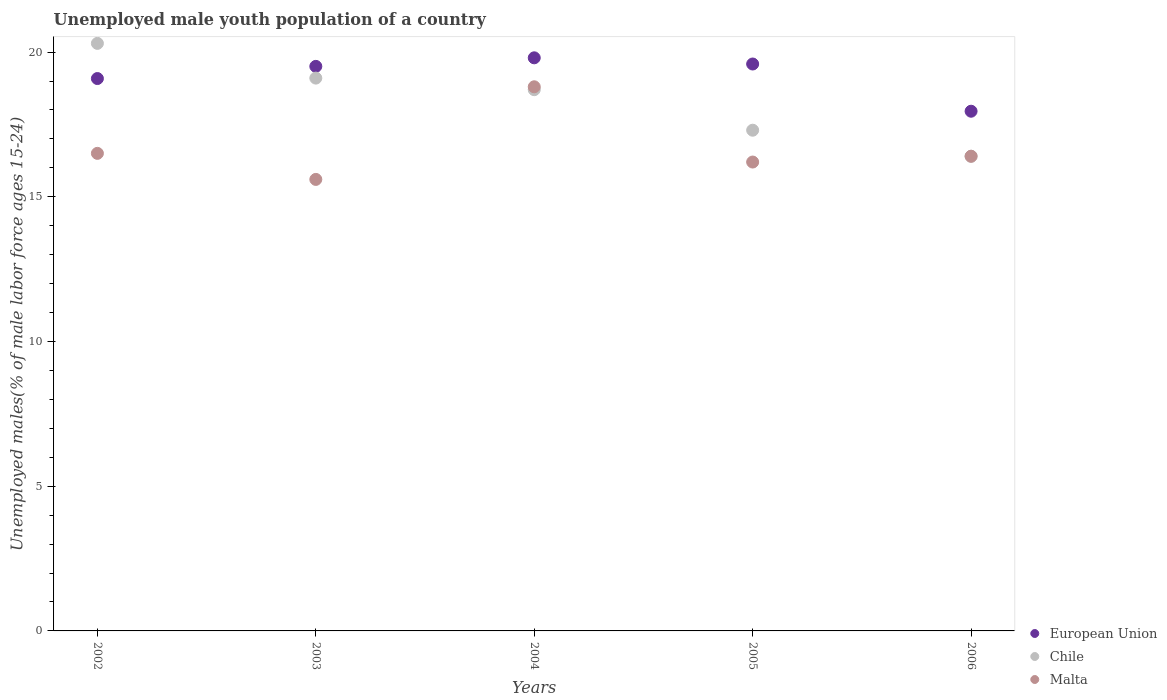Is the number of dotlines equal to the number of legend labels?
Provide a short and direct response. Yes. What is the percentage of unemployed male youth population in European Union in 2003?
Ensure brevity in your answer.  19.51. Across all years, what is the maximum percentage of unemployed male youth population in European Union?
Offer a very short reply. 19.8. Across all years, what is the minimum percentage of unemployed male youth population in Chile?
Make the answer very short. 16.4. In which year was the percentage of unemployed male youth population in Malta maximum?
Provide a succinct answer. 2004. What is the total percentage of unemployed male youth population in Malta in the graph?
Ensure brevity in your answer.  83.5. What is the difference between the percentage of unemployed male youth population in European Union in 2003 and that in 2006?
Ensure brevity in your answer.  1.55. What is the average percentage of unemployed male youth population in Chile per year?
Provide a succinct answer. 18.36. In the year 2003, what is the difference between the percentage of unemployed male youth population in European Union and percentage of unemployed male youth population in Malta?
Your response must be concise. 3.91. What is the ratio of the percentage of unemployed male youth population in European Union in 2002 to that in 2005?
Ensure brevity in your answer.  0.97. Is the percentage of unemployed male youth population in European Union in 2002 less than that in 2006?
Your answer should be compact. No. What is the difference between the highest and the second highest percentage of unemployed male youth population in European Union?
Provide a short and direct response. 0.21. What is the difference between the highest and the lowest percentage of unemployed male youth population in Malta?
Provide a short and direct response. 3.2. In how many years, is the percentage of unemployed male youth population in European Union greater than the average percentage of unemployed male youth population in European Union taken over all years?
Provide a succinct answer. 3. Is the percentage of unemployed male youth population in Chile strictly less than the percentage of unemployed male youth population in Malta over the years?
Offer a terse response. No. How many years are there in the graph?
Give a very brief answer. 5. What is the difference between two consecutive major ticks on the Y-axis?
Give a very brief answer. 5. Are the values on the major ticks of Y-axis written in scientific E-notation?
Your answer should be compact. No. How many legend labels are there?
Your response must be concise. 3. How are the legend labels stacked?
Keep it short and to the point. Vertical. What is the title of the graph?
Your answer should be very brief. Unemployed male youth population of a country. Does "High income: OECD" appear as one of the legend labels in the graph?
Keep it short and to the point. No. What is the label or title of the Y-axis?
Your answer should be compact. Unemployed males(% of male labor force ages 15-24). What is the Unemployed males(% of male labor force ages 15-24) in European Union in 2002?
Give a very brief answer. 19.08. What is the Unemployed males(% of male labor force ages 15-24) in Chile in 2002?
Your response must be concise. 20.3. What is the Unemployed males(% of male labor force ages 15-24) of Malta in 2002?
Offer a terse response. 16.5. What is the Unemployed males(% of male labor force ages 15-24) in European Union in 2003?
Offer a terse response. 19.51. What is the Unemployed males(% of male labor force ages 15-24) of Chile in 2003?
Provide a short and direct response. 19.1. What is the Unemployed males(% of male labor force ages 15-24) in Malta in 2003?
Offer a very short reply. 15.6. What is the Unemployed males(% of male labor force ages 15-24) of European Union in 2004?
Make the answer very short. 19.8. What is the Unemployed males(% of male labor force ages 15-24) in Chile in 2004?
Make the answer very short. 18.7. What is the Unemployed males(% of male labor force ages 15-24) in Malta in 2004?
Provide a succinct answer. 18.8. What is the Unemployed males(% of male labor force ages 15-24) of European Union in 2005?
Offer a terse response. 19.59. What is the Unemployed males(% of male labor force ages 15-24) in Chile in 2005?
Ensure brevity in your answer.  17.3. What is the Unemployed males(% of male labor force ages 15-24) of Malta in 2005?
Your response must be concise. 16.2. What is the Unemployed males(% of male labor force ages 15-24) of European Union in 2006?
Provide a short and direct response. 17.96. What is the Unemployed males(% of male labor force ages 15-24) in Chile in 2006?
Offer a very short reply. 16.4. What is the Unemployed males(% of male labor force ages 15-24) of Malta in 2006?
Give a very brief answer. 16.4. Across all years, what is the maximum Unemployed males(% of male labor force ages 15-24) in European Union?
Offer a terse response. 19.8. Across all years, what is the maximum Unemployed males(% of male labor force ages 15-24) in Chile?
Provide a short and direct response. 20.3. Across all years, what is the maximum Unemployed males(% of male labor force ages 15-24) in Malta?
Give a very brief answer. 18.8. Across all years, what is the minimum Unemployed males(% of male labor force ages 15-24) of European Union?
Your answer should be very brief. 17.96. Across all years, what is the minimum Unemployed males(% of male labor force ages 15-24) in Chile?
Keep it short and to the point. 16.4. Across all years, what is the minimum Unemployed males(% of male labor force ages 15-24) in Malta?
Make the answer very short. 15.6. What is the total Unemployed males(% of male labor force ages 15-24) of European Union in the graph?
Provide a succinct answer. 95.93. What is the total Unemployed males(% of male labor force ages 15-24) in Chile in the graph?
Your answer should be compact. 91.8. What is the total Unemployed males(% of male labor force ages 15-24) of Malta in the graph?
Your answer should be compact. 83.5. What is the difference between the Unemployed males(% of male labor force ages 15-24) in European Union in 2002 and that in 2003?
Offer a terse response. -0.42. What is the difference between the Unemployed males(% of male labor force ages 15-24) in European Union in 2002 and that in 2004?
Your response must be concise. -0.72. What is the difference between the Unemployed males(% of male labor force ages 15-24) in Chile in 2002 and that in 2004?
Keep it short and to the point. 1.6. What is the difference between the Unemployed males(% of male labor force ages 15-24) in Malta in 2002 and that in 2004?
Provide a short and direct response. -2.3. What is the difference between the Unemployed males(% of male labor force ages 15-24) in European Union in 2002 and that in 2005?
Provide a succinct answer. -0.5. What is the difference between the Unemployed males(% of male labor force ages 15-24) in European Union in 2002 and that in 2006?
Your answer should be compact. 1.13. What is the difference between the Unemployed males(% of male labor force ages 15-24) in European Union in 2003 and that in 2004?
Keep it short and to the point. -0.3. What is the difference between the Unemployed males(% of male labor force ages 15-24) of Malta in 2003 and that in 2004?
Make the answer very short. -3.2. What is the difference between the Unemployed males(% of male labor force ages 15-24) of European Union in 2003 and that in 2005?
Your answer should be compact. -0.08. What is the difference between the Unemployed males(% of male labor force ages 15-24) of Chile in 2003 and that in 2005?
Your answer should be very brief. 1.8. What is the difference between the Unemployed males(% of male labor force ages 15-24) of Malta in 2003 and that in 2005?
Your answer should be compact. -0.6. What is the difference between the Unemployed males(% of male labor force ages 15-24) of European Union in 2003 and that in 2006?
Ensure brevity in your answer.  1.55. What is the difference between the Unemployed males(% of male labor force ages 15-24) of Chile in 2003 and that in 2006?
Make the answer very short. 2.7. What is the difference between the Unemployed males(% of male labor force ages 15-24) of European Union in 2004 and that in 2005?
Give a very brief answer. 0.21. What is the difference between the Unemployed males(% of male labor force ages 15-24) in Malta in 2004 and that in 2005?
Give a very brief answer. 2.6. What is the difference between the Unemployed males(% of male labor force ages 15-24) of European Union in 2004 and that in 2006?
Ensure brevity in your answer.  1.85. What is the difference between the Unemployed males(% of male labor force ages 15-24) in European Union in 2005 and that in 2006?
Provide a succinct answer. 1.63. What is the difference between the Unemployed males(% of male labor force ages 15-24) in Malta in 2005 and that in 2006?
Keep it short and to the point. -0.2. What is the difference between the Unemployed males(% of male labor force ages 15-24) in European Union in 2002 and the Unemployed males(% of male labor force ages 15-24) in Chile in 2003?
Offer a terse response. -0.02. What is the difference between the Unemployed males(% of male labor force ages 15-24) in European Union in 2002 and the Unemployed males(% of male labor force ages 15-24) in Malta in 2003?
Keep it short and to the point. 3.48. What is the difference between the Unemployed males(% of male labor force ages 15-24) of Chile in 2002 and the Unemployed males(% of male labor force ages 15-24) of Malta in 2003?
Offer a very short reply. 4.7. What is the difference between the Unemployed males(% of male labor force ages 15-24) in European Union in 2002 and the Unemployed males(% of male labor force ages 15-24) in Chile in 2004?
Provide a short and direct response. 0.38. What is the difference between the Unemployed males(% of male labor force ages 15-24) of European Union in 2002 and the Unemployed males(% of male labor force ages 15-24) of Malta in 2004?
Provide a short and direct response. 0.28. What is the difference between the Unemployed males(% of male labor force ages 15-24) in European Union in 2002 and the Unemployed males(% of male labor force ages 15-24) in Chile in 2005?
Your answer should be compact. 1.78. What is the difference between the Unemployed males(% of male labor force ages 15-24) in European Union in 2002 and the Unemployed males(% of male labor force ages 15-24) in Malta in 2005?
Your response must be concise. 2.88. What is the difference between the Unemployed males(% of male labor force ages 15-24) in Chile in 2002 and the Unemployed males(% of male labor force ages 15-24) in Malta in 2005?
Your answer should be very brief. 4.1. What is the difference between the Unemployed males(% of male labor force ages 15-24) of European Union in 2002 and the Unemployed males(% of male labor force ages 15-24) of Chile in 2006?
Provide a succinct answer. 2.68. What is the difference between the Unemployed males(% of male labor force ages 15-24) in European Union in 2002 and the Unemployed males(% of male labor force ages 15-24) in Malta in 2006?
Your response must be concise. 2.68. What is the difference between the Unemployed males(% of male labor force ages 15-24) in European Union in 2003 and the Unemployed males(% of male labor force ages 15-24) in Chile in 2004?
Provide a succinct answer. 0.81. What is the difference between the Unemployed males(% of male labor force ages 15-24) of European Union in 2003 and the Unemployed males(% of male labor force ages 15-24) of Malta in 2004?
Give a very brief answer. 0.71. What is the difference between the Unemployed males(% of male labor force ages 15-24) in European Union in 2003 and the Unemployed males(% of male labor force ages 15-24) in Chile in 2005?
Offer a terse response. 2.21. What is the difference between the Unemployed males(% of male labor force ages 15-24) in European Union in 2003 and the Unemployed males(% of male labor force ages 15-24) in Malta in 2005?
Provide a succinct answer. 3.31. What is the difference between the Unemployed males(% of male labor force ages 15-24) in Chile in 2003 and the Unemployed males(% of male labor force ages 15-24) in Malta in 2005?
Your response must be concise. 2.9. What is the difference between the Unemployed males(% of male labor force ages 15-24) of European Union in 2003 and the Unemployed males(% of male labor force ages 15-24) of Chile in 2006?
Offer a very short reply. 3.11. What is the difference between the Unemployed males(% of male labor force ages 15-24) of European Union in 2003 and the Unemployed males(% of male labor force ages 15-24) of Malta in 2006?
Keep it short and to the point. 3.11. What is the difference between the Unemployed males(% of male labor force ages 15-24) of European Union in 2004 and the Unemployed males(% of male labor force ages 15-24) of Chile in 2005?
Provide a succinct answer. 2.5. What is the difference between the Unemployed males(% of male labor force ages 15-24) of European Union in 2004 and the Unemployed males(% of male labor force ages 15-24) of Malta in 2005?
Your response must be concise. 3.6. What is the difference between the Unemployed males(% of male labor force ages 15-24) in European Union in 2004 and the Unemployed males(% of male labor force ages 15-24) in Chile in 2006?
Keep it short and to the point. 3.4. What is the difference between the Unemployed males(% of male labor force ages 15-24) of European Union in 2004 and the Unemployed males(% of male labor force ages 15-24) of Malta in 2006?
Offer a very short reply. 3.4. What is the difference between the Unemployed males(% of male labor force ages 15-24) in Chile in 2004 and the Unemployed males(% of male labor force ages 15-24) in Malta in 2006?
Offer a terse response. 2.3. What is the difference between the Unemployed males(% of male labor force ages 15-24) in European Union in 2005 and the Unemployed males(% of male labor force ages 15-24) in Chile in 2006?
Provide a short and direct response. 3.19. What is the difference between the Unemployed males(% of male labor force ages 15-24) in European Union in 2005 and the Unemployed males(% of male labor force ages 15-24) in Malta in 2006?
Offer a terse response. 3.19. What is the difference between the Unemployed males(% of male labor force ages 15-24) in Chile in 2005 and the Unemployed males(% of male labor force ages 15-24) in Malta in 2006?
Your answer should be compact. 0.9. What is the average Unemployed males(% of male labor force ages 15-24) in European Union per year?
Your answer should be very brief. 19.19. What is the average Unemployed males(% of male labor force ages 15-24) of Chile per year?
Offer a very short reply. 18.36. What is the average Unemployed males(% of male labor force ages 15-24) in Malta per year?
Offer a very short reply. 16.7. In the year 2002, what is the difference between the Unemployed males(% of male labor force ages 15-24) in European Union and Unemployed males(% of male labor force ages 15-24) in Chile?
Keep it short and to the point. -1.22. In the year 2002, what is the difference between the Unemployed males(% of male labor force ages 15-24) in European Union and Unemployed males(% of male labor force ages 15-24) in Malta?
Ensure brevity in your answer.  2.58. In the year 2003, what is the difference between the Unemployed males(% of male labor force ages 15-24) of European Union and Unemployed males(% of male labor force ages 15-24) of Chile?
Your answer should be compact. 0.41. In the year 2003, what is the difference between the Unemployed males(% of male labor force ages 15-24) of European Union and Unemployed males(% of male labor force ages 15-24) of Malta?
Your response must be concise. 3.91. In the year 2004, what is the difference between the Unemployed males(% of male labor force ages 15-24) of European Union and Unemployed males(% of male labor force ages 15-24) of Chile?
Your answer should be compact. 1.1. In the year 2004, what is the difference between the Unemployed males(% of male labor force ages 15-24) of European Union and Unemployed males(% of male labor force ages 15-24) of Malta?
Make the answer very short. 1. In the year 2005, what is the difference between the Unemployed males(% of male labor force ages 15-24) of European Union and Unemployed males(% of male labor force ages 15-24) of Chile?
Your response must be concise. 2.29. In the year 2005, what is the difference between the Unemployed males(% of male labor force ages 15-24) in European Union and Unemployed males(% of male labor force ages 15-24) in Malta?
Your answer should be compact. 3.39. In the year 2005, what is the difference between the Unemployed males(% of male labor force ages 15-24) of Chile and Unemployed males(% of male labor force ages 15-24) of Malta?
Ensure brevity in your answer.  1.1. In the year 2006, what is the difference between the Unemployed males(% of male labor force ages 15-24) in European Union and Unemployed males(% of male labor force ages 15-24) in Chile?
Your answer should be very brief. 1.56. In the year 2006, what is the difference between the Unemployed males(% of male labor force ages 15-24) in European Union and Unemployed males(% of male labor force ages 15-24) in Malta?
Provide a succinct answer. 1.56. What is the ratio of the Unemployed males(% of male labor force ages 15-24) of European Union in 2002 to that in 2003?
Keep it short and to the point. 0.98. What is the ratio of the Unemployed males(% of male labor force ages 15-24) in Chile in 2002 to that in 2003?
Your answer should be compact. 1.06. What is the ratio of the Unemployed males(% of male labor force ages 15-24) in Malta in 2002 to that in 2003?
Provide a succinct answer. 1.06. What is the ratio of the Unemployed males(% of male labor force ages 15-24) in European Union in 2002 to that in 2004?
Offer a terse response. 0.96. What is the ratio of the Unemployed males(% of male labor force ages 15-24) of Chile in 2002 to that in 2004?
Provide a succinct answer. 1.09. What is the ratio of the Unemployed males(% of male labor force ages 15-24) in Malta in 2002 to that in 2004?
Give a very brief answer. 0.88. What is the ratio of the Unemployed males(% of male labor force ages 15-24) in European Union in 2002 to that in 2005?
Your answer should be very brief. 0.97. What is the ratio of the Unemployed males(% of male labor force ages 15-24) in Chile in 2002 to that in 2005?
Provide a short and direct response. 1.17. What is the ratio of the Unemployed males(% of male labor force ages 15-24) in Malta in 2002 to that in 2005?
Ensure brevity in your answer.  1.02. What is the ratio of the Unemployed males(% of male labor force ages 15-24) of European Union in 2002 to that in 2006?
Provide a succinct answer. 1.06. What is the ratio of the Unemployed males(% of male labor force ages 15-24) of Chile in 2002 to that in 2006?
Keep it short and to the point. 1.24. What is the ratio of the Unemployed males(% of male labor force ages 15-24) in European Union in 2003 to that in 2004?
Your answer should be very brief. 0.99. What is the ratio of the Unemployed males(% of male labor force ages 15-24) in Chile in 2003 to that in 2004?
Provide a short and direct response. 1.02. What is the ratio of the Unemployed males(% of male labor force ages 15-24) of Malta in 2003 to that in 2004?
Offer a very short reply. 0.83. What is the ratio of the Unemployed males(% of male labor force ages 15-24) in European Union in 2003 to that in 2005?
Offer a very short reply. 1. What is the ratio of the Unemployed males(% of male labor force ages 15-24) in Chile in 2003 to that in 2005?
Provide a succinct answer. 1.1. What is the ratio of the Unemployed males(% of male labor force ages 15-24) of Malta in 2003 to that in 2005?
Give a very brief answer. 0.96. What is the ratio of the Unemployed males(% of male labor force ages 15-24) in European Union in 2003 to that in 2006?
Give a very brief answer. 1.09. What is the ratio of the Unemployed males(% of male labor force ages 15-24) of Chile in 2003 to that in 2006?
Give a very brief answer. 1.16. What is the ratio of the Unemployed males(% of male labor force ages 15-24) in Malta in 2003 to that in 2006?
Keep it short and to the point. 0.95. What is the ratio of the Unemployed males(% of male labor force ages 15-24) of European Union in 2004 to that in 2005?
Offer a terse response. 1.01. What is the ratio of the Unemployed males(% of male labor force ages 15-24) of Chile in 2004 to that in 2005?
Your answer should be very brief. 1.08. What is the ratio of the Unemployed males(% of male labor force ages 15-24) of Malta in 2004 to that in 2005?
Your answer should be compact. 1.16. What is the ratio of the Unemployed males(% of male labor force ages 15-24) in European Union in 2004 to that in 2006?
Offer a terse response. 1.1. What is the ratio of the Unemployed males(% of male labor force ages 15-24) of Chile in 2004 to that in 2006?
Make the answer very short. 1.14. What is the ratio of the Unemployed males(% of male labor force ages 15-24) of Malta in 2004 to that in 2006?
Your response must be concise. 1.15. What is the ratio of the Unemployed males(% of male labor force ages 15-24) of European Union in 2005 to that in 2006?
Your answer should be compact. 1.09. What is the ratio of the Unemployed males(% of male labor force ages 15-24) in Chile in 2005 to that in 2006?
Offer a terse response. 1.05. What is the difference between the highest and the second highest Unemployed males(% of male labor force ages 15-24) in European Union?
Your answer should be compact. 0.21. What is the difference between the highest and the second highest Unemployed males(% of male labor force ages 15-24) in Chile?
Your answer should be very brief. 1.2. What is the difference between the highest and the second highest Unemployed males(% of male labor force ages 15-24) of Malta?
Offer a terse response. 2.3. What is the difference between the highest and the lowest Unemployed males(% of male labor force ages 15-24) in European Union?
Ensure brevity in your answer.  1.85. What is the difference between the highest and the lowest Unemployed males(% of male labor force ages 15-24) of Malta?
Your answer should be very brief. 3.2. 